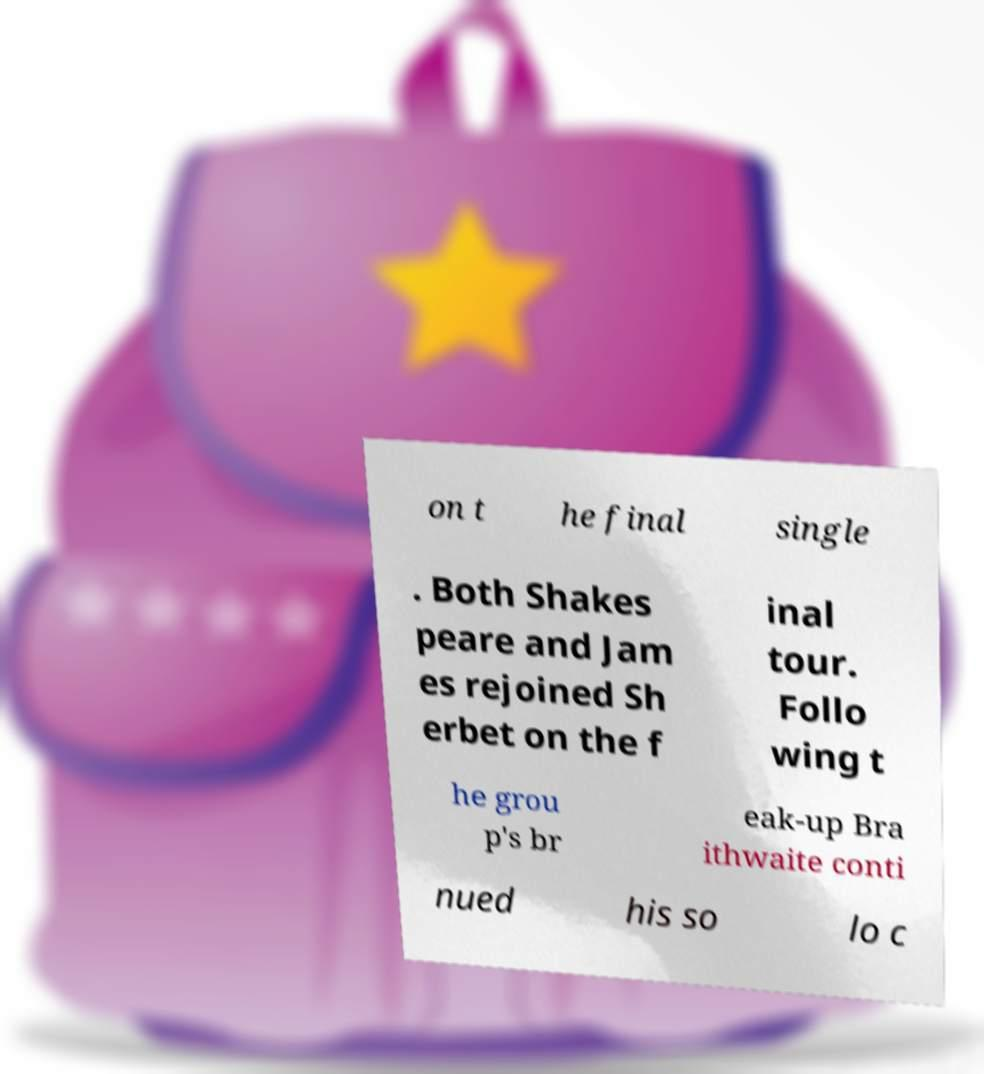Can you accurately transcribe the text from the provided image for me? on t he final single . Both Shakes peare and Jam es rejoined Sh erbet on the f inal tour. Follo wing t he grou p's br eak-up Bra ithwaite conti nued his so lo c 